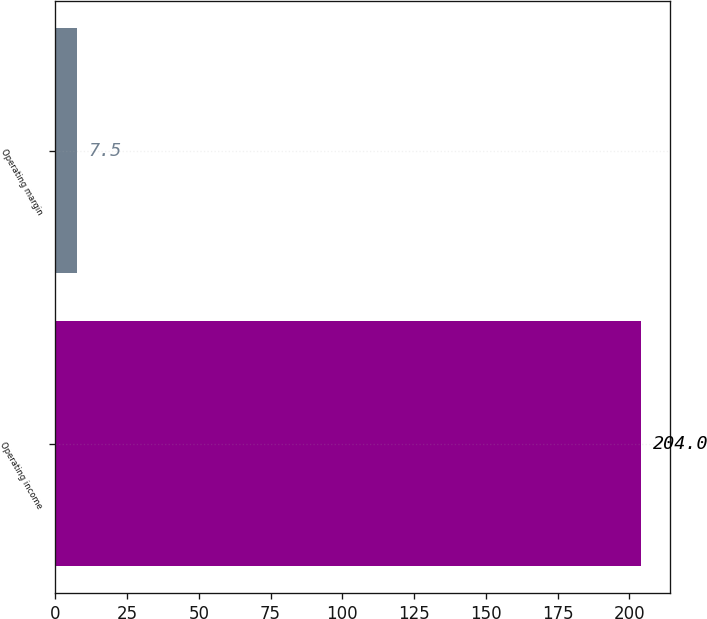Convert chart. <chart><loc_0><loc_0><loc_500><loc_500><bar_chart><fcel>Operating income<fcel>Operating margin<nl><fcel>204<fcel>7.5<nl></chart> 